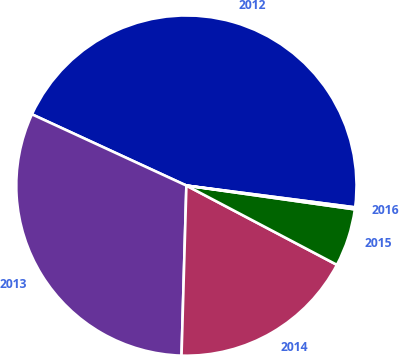Convert chart to OTSL. <chart><loc_0><loc_0><loc_500><loc_500><pie_chart><fcel>2012<fcel>2013<fcel>2014<fcel>2015<fcel>2016<nl><fcel>45.16%<fcel>31.42%<fcel>17.74%<fcel>5.48%<fcel>0.19%<nl></chart> 